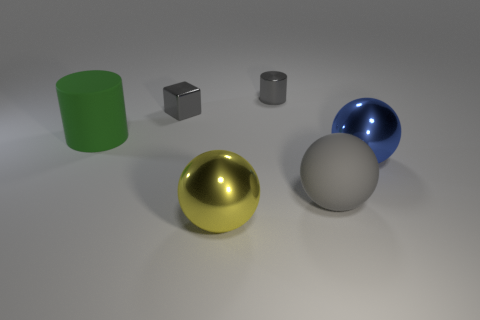Subtract all gray spheres. How many spheres are left? 2 Subtract all blue balls. How many balls are left? 2 Add 3 small gray cubes. How many objects exist? 9 Subtract 2 cylinders. How many cylinders are left? 0 Subtract all big blue metal objects. Subtract all gray matte things. How many objects are left? 4 Add 3 small metal cubes. How many small metal cubes are left? 4 Add 6 tiny metallic cubes. How many tiny metallic cubes exist? 7 Subtract 1 gray blocks. How many objects are left? 5 Subtract all blocks. How many objects are left? 5 Subtract all green cylinders. Subtract all green spheres. How many cylinders are left? 1 